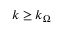<formula> <loc_0><loc_0><loc_500><loc_500>k \geq k _ { \Omega }</formula> 